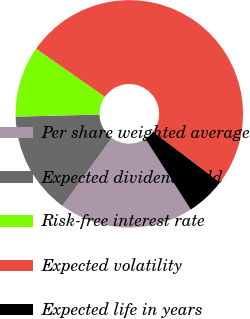Convert chart to OTSL. <chart><loc_0><loc_0><loc_500><loc_500><pie_chart><fcel>Per share weighted average<fcel>Expected dividend yield<fcel>Risk-free interest rate<fcel>Expected volatility<fcel>Expected life in years<nl><fcel>19.1%<fcel>14.6%<fcel>10.1%<fcel>50.61%<fcel>5.59%<nl></chart> 